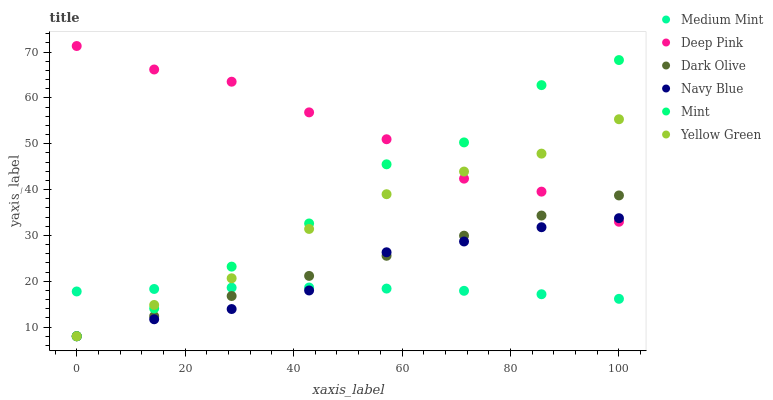Does Medium Mint have the minimum area under the curve?
Answer yes or no. Yes. Does Deep Pink have the maximum area under the curve?
Answer yes or no. Yes. Does Yellow Green have the minimum area under the curve?
Answer yes or no. No. Does Yellow Green have the maximum area under the curve?
Answer yes or no. No. Is Dark Olive the smoothest?
Answer yes or no. Yes. Is Mint the roughest?
Answer yes or no. Yes. Is Deep Pink the smoothest?
Answer yes or no. No. Is Deep Pink the roughest?
Answer yes or no. No. Does Yellow Green have the lowest value?
Answer yes or no. Yes. Does Deep Pink have the lowest value?
Answer yes or no. No. Does Deep Pink have the highest value?
Answer yes or no. Yes. Does Yellow Green have the highest value?
Answer yes or no. No. Is Medium Mint less than Deep Pink?
Answer yes or no. Yes. Is Deep Pink greater than Medium Mint?
Answer yes or no. Yes. Does Mint intersect Dark Olive?
Answer yes or no. Yes. Is Mint less than Dark Olive?
Answer yes or no. No. Is Mint greater than Dark Olive?
Answer yes or no. No. Does Medium Mint intersect Deep Pink?
Answer yes or no. No. 